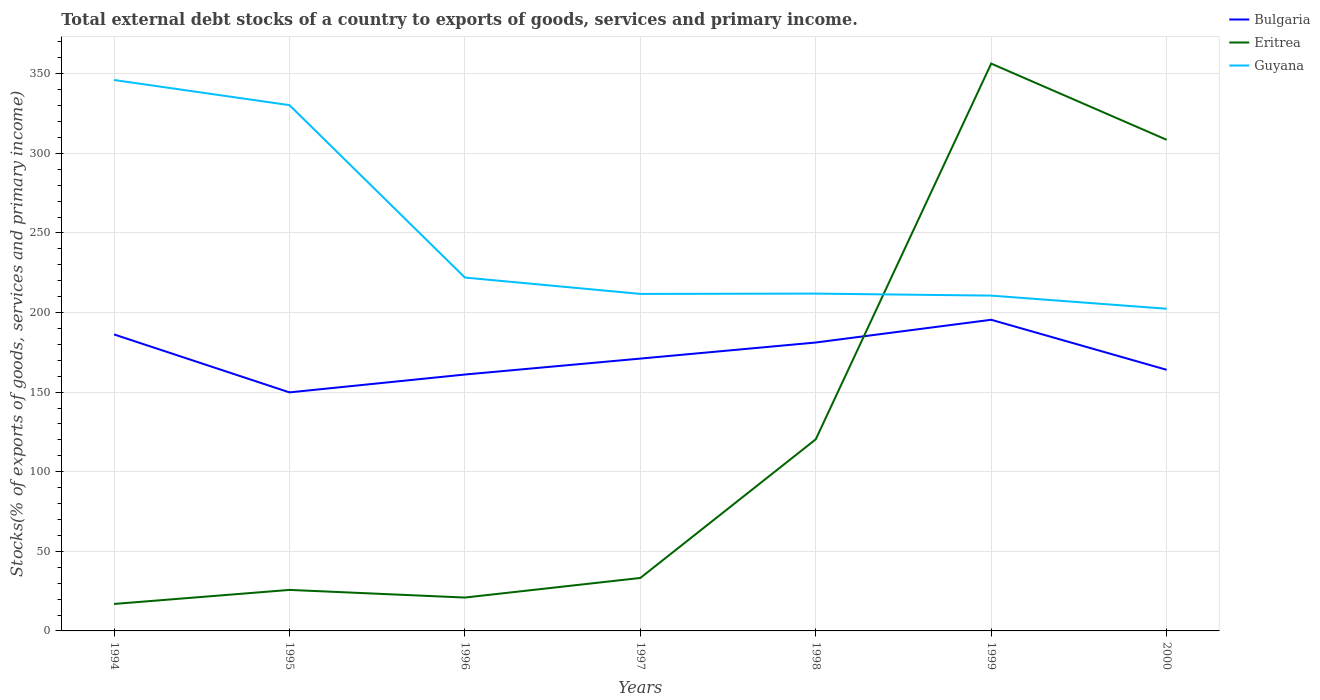How many different coloured lines are there?
Make the answer very short. 3. Does the line corresponding to Guyana intersect with the line corresponding to Bulgaria?
Provide a short and direct response. No. Is the number of lines equal to the number of legend labels?
Your answer should be compact. Yes. Across all years, what is the maximum total debt stocks in Eritrea?
Ensure brevity in your answer.  16.94. What is the total total debt stocks in Bulgaria in the graph?
Make the answer very short. -11.22. What is the difference between the highest and the second highest total debt stocks in Guyana?
Make the answer very short. 143.7. What is the difference between the highest and the lowest total debt stocks in Bulgaria?
Make the answer very short. 3. How many years are there in the graph?
Offer a terse response. 7. Are the values on the major ticks of Y-axis written in scientific E-notation?
Your answer should be very brief. No. What is the title of the graph?
Your answer should be compact. Total external debt stocks of a country to exports of goods, services and primary income. Does "Northern Mariana Islands" appear as one of the legend labels in the graph?
Offer a terse response. No. What is the label or title of the Y-axis?
Your response must be concise. Stocks(% of exports of goods, services and primary income). What is the Stocks(% of exports of goods, services and primary income) of Bulgaria in 1994?
Give a very brief answer. 186.26. What is the Stocks(% of exports of goods, services and primary income) of Eritrea in 1994?
Provide a succinct answer. 16.94. What is the Stocks(% of exports of goods, services and primary income) in Guyana in 1994?
Offer a very short reply. 346.09. What is the Stocks(% of exports of goods, services and primary income) in Bulgaria in 1995?
Your answer should be very brief. 149.85. What is the Stocks(% of exports of goods, services and primary income) of Eritrea in 1995?
Your answer should be very brief. 25.77. What is the Stocks(% of exports of goods, services and primary income) of Guyana in 1995?
Offer a terse response. 330.29. What is the Stocks(% of exports of goods, services and primary income) of Bulgaria in 1996?
Offer a terse response. 161.07. What is the Stocks(% of exports of goods, services and primary income) of Eritrea in 1996?
Provide a succinct answer. 20.97. What is the Stocks(% of exports of goods, services and primary income) in Guyana in 1996?
Offer a very short reply. 221.99. What is the Stocks(% of exports of goods, services and primary income) in Bulgaria in 1997?
Your response must be concise. 171.08. What is the Stocks(% of exports of goods, services and primary income) of Eritrea in 1997?
Make the answer very short. 33.27. What is the Stocks(% of exports of goods, services and primary income) in Guyana in 1997?
Your answer should be compact. 211.71. What is the Stocks(% of exports of goods, services and primary income) in Bulgaria in 1998?
Keep it short and to the point. 181.18. What is the Stocks(% of exports of goods, services and primary income) in Eritrea in 1998?
Make the answer very short. 120.36. What is the Stocks(% of exports of goods, services and primary income) of Guyana in 1998?
Give a very brief answer. 211.9. What is the Stocks(% of exports of goods, services and primary income) in Bulgaria in 1999?
Give a very brief answer. 195.46. What is the Stocks(% of exports of goods, services and primary income) in Eritrea in 1999?
Keep it short and to the point. 356.4. What is the Stocks(% of exports of goods, services and primary income) of Guyana in 1999?
Your answer should be compact. 210.64. What is the Stocks(% of exports of goods, services and primary income) of Bulgaria in 2000?
Your answer should be very brief. 164.04. What is the Stocks(% of exports of goods, services and primary income) in Eritrea in 2000?
Your response must be concise. 308.53. What is the Stocks(% of exports of goods, services and primary income) in Guyana in 2000?
Ensure brevity in your answer.  202.39. Across all years, what is the maximum Stocks(% of exports of goods, services and primary income) in Bulgaria?
Make the answer very short. 195.46. Across all years, what is the maximum Stocks(% of exports of goods, services and primary income) in Eritrea?
Offer a very short reply. 356.4. Across all years, what is the maximum Stocks(% of exports of goods, services and primary income) of Guyana?
Offer a very short reply. 346.09. Across all years, what is the minimum Stocks(% of exports of goods, services and primary income) of Bulgaria?
Ensure brevity in your answer.  149.85. Across all years, what is the minimum Stocks(% of exports of goods, services and primary income) in Eritrea?
Make the answer very short. 16.94. Across all years, what is the minimum Stocks(% of exports of goods, services and primary income) in Guyana?
Ensure brevity in your answer.  202.39. What is the total Stocks(% of exports of goods, services and primary income) in Bulgaria in the graph?
Ensure brevity in your answer.  1208.94. What is the total Stocks(% of exports of goods, services and primary income) in Eritrea in the graph?
Your response must be concise. 882.24. What is the total Stocks(% of exports of goods, services and primary income) in Guyana in the graph?
Your answer should be compact. 1735.02. What is the difference between the Stocks(% of exports of goods, services and primary income) of Bulgaria in 1994 and that in 1995?
Your answer should be compact. 36.41. What is the difference between the Stocks(% of exports of goods, services and primary income) of Eritrea in 1994 and that in 1995?
Keep it short and to the point. -8.82. What is the difference between the Stocks(% of exports of goods, services and primary income) of Guyana in 1994 and that in 1995?
Your answer should be very brief. 15.79. What is the difference between the Stocks(% of exports of goods, services and primary income) of Bulgaria in 1994 and that in 1996?
Ensure brevity in your answer.  25.19. What is the difference between the Stocks(% of exports of goods, services and primary income) in Eritrea in 1994 and that in 1996?
Make the answer very short. -4.03. What is the difference between the Stocks(% of exports of goods, services and primary income) of Guyana in 1994 and that in 1996?
Provide a succinct answer. 124.1. What is the difference between the Stocks(% of exports of goods, services and primary income) in Bulgaria in 1994 and that in 1997?
Your answer should be very brief. 15.18. What is the difference between the Stocks(% of exports of goods, services and primary income) in Eritrea in 1994 and that in 1997?
Your response must be concise. -16.33. What is the difference between the Stocks(% of exports of goods, services and primary income) of Guyana in 1994 and that in 1997?
Your answer should be compact. 134.38. What is the difference between the Stocks(% of exports of goods, services and primary income) in Bulgaria in 1994 and that in 1998?
Ensure brevity in your answer.  5.08. What is the difference between the Stocks(% of exports of goods, services and primary income) of Eritrea in 1994 and that in 1998?
Offer a terse response. -103.42. What is the difference between the Stocks(% of exports of goods, services and primary income) in Guyana in 1994 and that in 1998?
Offer a very short reply. 134.19. What is the difference between the Stocks(% of exports of goods, services and primary income) of Bulgaria in 1994 and that in 1999?
Provide a succinct answer. -9.2. What is the difference between the Stocks(% of exports of goods, services and primary income) of Eritrea in 1994 and that in 1999?
Your answer should be compact. -339.45. What is the difference between the Stocks(% of exports of goods, services and primary income) in Guyana in 1994 and that in 1999?
Your response must be concise. 135.45. What is the difference between the Stocks(% of exports of goods, services and primary income) in Bulgaria in 1994 and that in 2000?
Offer a terse response. 22.22. What is the difference between the Stocks(% of exports of goods, services and primary income) in Eritrea in 1994 and that in 2000?
Make the answer very short. -291.59. What is the difference between the Stocks(% of exports of goods, services and primary income) of Guyana in 1994 and that in 2000?
Give a very brief answer. 143.7. What is the difference between the Stocks(% of exports of goods, services and primary income) of Bulgaria in 1995 and that in 1996?
Offer a very short reply. -11.22. What is the difference between the Stocks(% of exports of goods, services and primary income) in Eritrea in 1995 and that in 1996?
Provide a short and direct response. 4.8. What is the difference between the Stocks(% of exports of goods, services and primary income) in Guyana in 1995 and that in 1996?
Your answer should be compact. 108.3. What is the difference between the Stocks(% of exports of goods, services and primary income) of Bulgaria in 1995 and that in 1997?
Keep it short and to the point. -21.23. What is the difference between the Stocks(% of exports of goods, services and primary income) of Eritrea in 1995 and that in 1997?
Keep it short and to the point. -7.5. What is the difference between the Stocks(% of exports of goods, services and primary income) in Guyana in 1995 and that in 1997?
Give a very brief answer. 118.58. What is the difference between the Stocks(% of exports of goods, services and primary income) in Bulgaria in 1995 and that in 1998?
Provide a short and direct response. -31.33. What is the difference between the Stocks(% of exports of goods, services and primary income) in Eritrea in 1995 and that in 1998?
Your response must be concise. -94.6. What is the difference between the Stocks(% of exports of goods, services and primary income) in Guyana in 1995 and that in 1998?
Offer a terse response. 118.39. What is the difference between the Stocks(% of exports of goods, services and primary income) of Bulgaria in 1995 and that in 1999?
Offer a terse response. -45.61. What is the difference between the Stocks(% of exports of goods, services and primary income) of Eritrea in 1995 and that in 1999?
Offer a terse response. -330.63. What is the difference between the Stocks(% of exports of goods, services and primary income) of Guyana in 1995 and that in 1999?
Provide a short and direct response. 119.65. What is the difference between the Stocks(% of exports of goods, services and primary income) of Bulgaria in 1995 and that in 2000?
Your response must be concise. -14.19. What is the difference between the Stocks(% of exports of goods, services and primary income) of Eritrea in 1995 and that in 2000?
Provide a succinct answer. -282.76. What is the difference between the Stocks(% of exports of goods, services and primary income) of Guyana in 1995 and that in 2000?
Keep it short and to the point. 127.9. What is the difference between the Stocks(% of exports of goods, services and primary income) in Bulgaria in 1996 and that in 1997?
Offer a terse response. -10.01. What is the difference between the Stocks(% of exports of goods, services and primary income) in Eritrea in 1996 and that in 1997?
Make the answer very short. -12.3. What is the difference between the Stocks(% of exports of goods, services and primary income) in Guyana in 1996 and that in 1997?
Provide a short and direct response. 10.28. What is the difference between the Stocks(% of exports of goods, services and primary income) in Bulgaria in 1996 and that in 1998?
Give a very brief answer. -20.11. What is the difference between the Stocks(% of exports of goods, services and primary income) in Eritrea in 1996 and that in 1998?
Your answer should be compact. -99.39. What is the difference between the Stocks(% of exports of goods, services and primary income) in Guyana in 1996 and that in 1998?
Keep it short and to the point. 10.09. What is the difference between the Stocks(% of exports of goods, services and primary income) of Bulgaria in 1996 and that in 1999?
Offer a very short reply. -34.39. What is the difference between the Stocks(% of exports of goods, services and primary income) of Eritrea in 1996 and that in 1999?
Offer a terse response. -335.43. What is the difference between the Stocks(% of exports of goods, services and primary income) in Guyana in 1996 and that in 1999?
Your answer should be very brief. 11.35. What is the difference between the Stocks(% of exports of goods, services and primary income) in Bulgaria in 1996 and that in 2000?
Offer a terse response. -2.97. What is the difference between the Stocks(% of exports of goods, services and primary income) of Eritrea in 1996 and that in 2000?
Offer a terse response. -287.56. What is the difference between the Stocks(% of exports of goods, services and primary income) of Guyana in 1996 and that in 2000?
Give a very brief answer. 19.6. What is the difference between the Stocks(% of exports of goods, services and primary income) of Bulgaria in 1997 and that in 1998?
Offer a terse response. -10.1. What is the difference between the Stocks(% of exports of goods, services and primary income) in Eritrea in 1997 and that in 1998?
Make the answer very short. -87.09. What is the difference between the Stocks(% of exports of goods, services and primary income) in Guyana in 1997 and that in 1998?
Offer a terse response. -0.19. What is the difference between the Stocks(% of exports of goods, services and primary income) in Bulgaria in 1997 and that in 1999?
Your response must be concise. -24.38. What is the difference between the Stocks(% of exports of goods, services and primary income) in Eritrea in 1997 and that in 1999?
Ensure brevity in your answer.  -323.12. What is the difference between the Stocks(% of exports of goods, services and primary income) of Guyana in 1997 and that in 1999?
Give a very brief answer. 1.07. What is the difference between the Stocks(% of exports of goods, services and primary income) in Bulgaria in 1997 and that in 2000?
Give a very brief answer. 7.04. What is the difference between the Stocks(% of exports of goods, services and primary income) of Eritrea in 1997 and that in 2000?
Your answer should be very brief. -275.26. What is the difference between the Stocks(% of exports of goods, services and primary income) in Guyana in 1997 and that in 2000?
Give a very brief answer. 9.32. What is the difference between the Stocks(% of exports of goods, services and primary income) in Bulgaria in 1998 and that in 1999?
Your answer should be compact. -14.28. What is the difference between the Stocks(% of exports of goods, services and primary income) of Eritrea in 1998 and that in 1999?
Offer a very short reply. -236.03. What is the difference between the Stocks(% of exports of goods, services and primary income) of Guyana in 1998 and that in 1999?
Ensure brevity in your answer.  1.26. What is the difference between the Stocks(% of exports of goods, services and primary income) of Bulgaria in 1998 and that in 2000?
Give a very brief answer. 17.14. What is the difference between the Stocks(% of exports of goods, services and primary income) in Eritrea in 1998 and that in 2000?
Your answer should be compact. -188.17. What is the difference between the Stocks(% of exports of goods, services and primary income) in Guyana in 1998 and that in 2000?
Offer a terse response. 9.51. What is the difference between the Stocks(% of exports of goods, services and primary income) in Bulgaria in 1999 and that in 2000?
Make the answer very short. 31.42. What is the difference between the Stocks(% of exports of goods, services and primary income) in Eritrea in 1999 and that in 2000?
Ensure brevity in your answer.  47.86. What is the difference between the Stocks(% of exports of goods, services and primary income) in Guyana in 1999 and that in 2000?
Ensure brevity in your answer.  8.25. What is the difference between the Stocks(% of exports of goods, services and primary income) of Bulgaria in 1994 and the Stocks(% of exports of goods, services and primary income) of Eritrea in 1995?
Keep it short and to the point. 160.5. What is the difference between the Stocks(% of exports of goods, services and primary income) of Bulgaria in 1994 and the Stocks(% of exports of goods, services and primary income) of Guyana in 1995?
Ensure brevity in your answer.  -144.03. What is the difference between the Stocks(% of exports of goods, services and primary income) of Eritrea in 1994 and the Stocks(% of exports of goods, services and primary income) of Guyana in 1995?
Make the answer very short. -313.35. What is the difference between the Stocks(% of exports of goods, services and primary income) of Bulgaria in 1994 and the Stocks(% of exports of goods, services and primary income) of Eritrea in 1996?
Give a very brief answer. 165.29. What is the difference between the Stocks(% of exports of goods, services and primary income) in Bulgaria in 1994 and the Stocks(% of exports of goods, services and primary income) in Guyana in 1996?
Your answer should be very brief. -35.73. What is the difference between the Stocks(% of exports of goods, services and primary income) of Eritrea in 1994 and the Stocks(% of exports of goods, services and primary income) of Guyana in 1996?
Offer a terse response. -205.05. What is the difference between the Stocks(% of exports of goods, services and primary income) of Bulgaria in 1994 and the Stocks(% of exports of goods, services and primary income) of Eritrea in 1997?
Offer a very short reply. 152.99. What is the difference between the Stocks(% of exports of goods, services and primary income) of Bulgaria in 1994 and the Stocks(% of exports of goods, services and primary income) of Guyana in 1997?
Provide a succinct answer. -25.45. What is the difference between the Stocks(% of exports of goods, services and primary income) of Eritrea in 1994 and the Stocks(% of exports of goods, services and primary income) of Guyana in 1997?
Offer a very short reply. -194.77. What is the difference between the Stocks(% of exports of goods, services and primary income) in Bulgaria in 1994 and the Stocks(% of exports of goods, services and primary income) in Eritrea in 1998?
Your answer should be compact. 65.9. What is the difference between the Stocks(% of exports of goods, services and primary income) of Bulgaria in 1994 and the Stocks(% of exports of goods, services and primary income) of Guyana in 1998?
Give a very brief answer. -25.64. What is the difference between the Stocks(% of exports of goods, services and primary income) of Eritrea in 1994 and the Stocks(% of exports of goods, services and primary income) of Guyana in 1998?
Ensure brevity in your answer.  -194.96. What is the difference between the Stocks(% of exports of goods, services and primary income) of Bulgaria in 1994 and the Stocks(% of exports of goods, services and primary income) of Eritrea in 1999?
Provide a short and direct response. -170.13. What is the difference between the Stocks(% of exports of goods, services and primary income) of Bulgaria in 1994 and the Stocks(% of exports of goods, services and primary income) of Guyana in 1999?
Keep it short and to the point. -24.38. What is the difference between the Stocks(% of exports of goods, services and primary income) of Eritrea in 1994 and the Stocks(% of exports of goods, services and primary income) of Guyana in 1999?
Your response must be concise. -193.7. What is the difference between the Stocks(% of exports of goods, services and primary income) of Bulgaria in 1994 and the Stocks(% of exports of goods, services and primary income) of Eritrea in 2000?
Your response must be concise. -122.27. What is the difference between the Stocks(% of exports of goods, services and primary income) in Bulgaria in 1994 and the Stocks(% of exports of goods, services and primary income) in Guyana in 2000?
Ensure brevity in your answer.  -16.13. What is the difference between the Stocks(% of exports of goods, services and primary income) in Eritrea in 1994 and the Stocks(% of exports of goods, services and primary income) in Guyana in 2000?
Ensure brevity in your answer.  -185.45. What is the difference between the Stocks(% of exports of goods, services and primary income) in Bulgaria in 1995 and the Stocks(% of exports of goods, services and primary income) in Eritrea in 1996?
Provide a succinct answer. 128.88. What is the difference between the Stocks(% of exports of goods, services and primary income) of Bulgaria in 1995 and the Stocks(% of exports of goods, services and primary income) of Guyana in 1996?
Offer a very short reply. -72.14. What is the difference between the Stocks(% of exports of goods, services and primary income) of Eritrea in 1995 and the Stocks(% of exports of goods, services and primary income) of Guyana in 1996?
Your response must be concise. -196.22. What is the difference between the Stocks(% of exports of goods, services and primary income) of Bulgaria in 1995 and the Stocks(% of exports of goods, services and primary income) of Eritrea in 1997?
Keep it short and to the point. 116.58. What is the difference between the Stocks(% of exports of goods, services and primary income) in Bulgaria in 1995 and the Stocks(% of exports of goods, services and primary income) in Guyana in 1997?
Offer a terse response. -61.87. What is the difference between the Stocks(% of exports of goods, services and primary income) of Eritrea in 1995 and the Stocks(% of exports of goods, services and primary income) of Guyana in 1997?
Give a very brief answer. -185.95. What is the difference between the Stocks(% of exports of goods, services and primary income) of Bulgaria in 1995 and the Stocks(% of exports of goods, services and primary income) of Eritrea in 1998?
Make the answer very short. 29.49. What is the difference between the Stocks(% of exports of goods, services and primary income) in Bulgaria in 1995 and the Stocks(% of exports of goods, services and primary income) in Guyana in 1998?
Your response must be concise. -62.05. What is the difference between the Stocks(% of exports of goods, services and primary income) in Eritrea in 1995 and the Stocks(% of exports of goods, services and primary income) in Guyana in 1998?
Provide a succinct answer. -186.13. What is the difference between the Stocks(% of exports of goods, services and primary income) of Bulgaria in 1995 and the Stocks(% of exports of goods, services and primary income) of Eritrea in 1999?
Your answer should be very brief. -206.55. What is the difference between the Stocks(% of exports of goods, services and primary income) in Bulgaria in 1995 and the Stocks(% of exports of goods, services and primary income) in Guyana in 1999?
Provide a succinct answer. -60.79. What is the difference between the Stocks(% of exports of goods, services and primary income) of Eritrea in 1995 and the Stocks(% of exports of goods, services and primary income) of Guyana in 1999?
Offer a terse response. -184.88. What is the difference between the Stocks(% of exports of goods, services and primary income) of Bulgaria in 1995 and the Stocks(% of exports of goods, services and primary income) of Eritrea in 2000?
Your response must be concise. -158.68. What is the difference between the Stocks(% of exports of goods, services and primary income) of Bulgaria in 1995 and the Stocks(% of exports of goods, services and primary income) of Guyana in 2000?
Your answer should be very brief. -52.54. What is the difference between the Stocks(% of exports of goods, services and primary income) of Eritrea in 1995 and the Stocks(% of exports of goods, services and primary income) of Guyana in 2000?
Offer a very short reply. -176.62. What is the difference between the Stocks(% of exports of goods, services and primary income) in Bulgaria in 1996 and the Stocks(% of exports of goods, services and primary income) in Eritrea in 1997?
Ensure brevity in your answer.  127.8. What is the difference between the Stocks(% of exports of goods, services and primary income) in Bulgaria in 1996 and the Stocks(% of exports of goods, services and primary income) in Guyana in 1997?
Make the answer very short. -50.64. What is the difference between the Stocks(% of exports of goods, services and primary income) of Eritrea in 1996 and the Stocks(% of exports of goods, services and primary income) of Guyana in 1997?
Your answer should be compact. -190.74. What is the difference between the Stocks(% of exports of goods, services and primary income) of Bulgaria in 1996 and the Stocks(% of exports of goods, services and primary income) of Eritrea in 1998?
Provide a succinct answer. 40.71. What is the difference between the Stocks(% of exports of goods, services and primary income) in Bulgaria in 1996 and the Stocks(% of exports of goods, services and primary income) in Guyana in 1998?
Make the answer very short. -50.83. What is the difference between the Stocks(% of exports of goods, services and primary income) in Eritrea in 1996 and the Stocks(% of exports of goods, services and primary income) in Guyana in 1998?
Your answer should be compact. -190.93. What is the difference between the Stocks(% of exports of goods, services and primary income) in Bulgaria in 1996 and the Stocks(% of exports of goods, services and primary income) in Eritrea in 1999?
Offer a very short reply. -195.33. What is the difference between the Stocks(% of exports of goods, services and primary income) in Bulgaria in 1996 and the Stocks(% of exports of goods, services and primary income) in Guyana in 1999?
Provide a succinct answer. -49.57. What is the difference between the Stocks(% of exports of goods, services and primary income) of Eritrea in 1996 and the Stocks(% of exports of goods, services and primary income) of Guyana in 1999?
Ensure brevity in your answer.  -189.67. What is the difference between the Stocks(% of exports of goods, services and primary income) in Bulgaria in 1996 and the Stocks(% of exports of goods, services and primary income) in Eritrea in 2000?
Make the answer very short. -147.46. What is the difference between the Stocks(% of exports of goods, services and primary income) of Bulgaria in 1996 and the Stocks(% of exports of goods, services and primary income) of Guyana in 2000?
Provide a short and direct response. -41.32. What is the difference between the Stocks(% of exports of goods, services and primary income) in Eritrea in 1996 and the Stocks(% of exports of goods, services and primary income) in Guyana in 2000?
Offer a very short reply. -181.42. What is the difference between the Stocks(% of exports of goods, services and primary income) in Bulgaria in 1997 and the Stocks(% of exports of goods, services and primary income) in Eritrea in 1998?
Offer a terse response. 50.72. What is the difference between the Stocks(% of exports of goods, services and primary income) of Bulgaria in 1997 and the Stocks(% of exports of goods, services and primary income) of Guyana in 1998?
Offer a very short reply. -40.82. What is the difference between the Stocks(% of exports of goods, services and primary income) in Eritrea in 1997 and the Stocks(% of exports of goods, services and primary income) in Guyana in 1998?
Make the answer very short. -178.63. What is the difference between the Stocks(% of exports of goods, services and primary income) in Bulgaria in 1997 and the Stocks(% of exports of goods, services and primary income) in Eritrea in 1999?
Provide a short and direct response. -185.31. What is the difference between the Stocks(% of exports of goods, services and primary income) in Bulgaria in 1997 and the Stocks(% of exports of goods, services and primary income) in Guyana in 1999?
Your response must be concise. -39.56. What is the difference between the Stocks(% of exports of goods, services and primary income) in Eritrea in 1997 and the Stocks(% of exports of goods, services and primary income) in Guyana in 1999?
Your answer should be very brief. -177.37. What is the difference between the Stocks(% of exports of goods, services and primary income) in Bulgaria in 1997 and the Stocks(% of exports of goods, services and primary income) in Eritrea in 2000?
Make the answer very short. -137.45. What is the difference between the Stocks(% of exports of goods, services and primary income) of Bulgaria in 1997 and the Stocks(% of exports of goods, services and primary income) of Guyana in 2000?
Your answer should be compact. -31.31. What is the difference between the Stocks(% of exports of goods, services and primary income) of Eritrea in 1997 and the Stocks(% of exports of goods, services and primary income) of Guyana in 2000?
Your answer should be compact. -169.12. What is the difference between the Stocks(% of exports of goods, services and primary income) of Bulgaria in 1998 and the Stocks(% of exports of goods, services and primary income) of Eritrea in 1999?
Your answer should be very brief. -175.22. What is the difference between the Stocks(% of exports of goods, services and primary income) in Bulgaria in 1998 and the Stocks(% of exports of goods, services and primary income) in Guyana in 1999?
Give a very brief answer. -29.46. What is the difference between the Stocks(% of exports of goods, services and primary income) of Eritrea in 1998 and the Stocks(% of exports of goods, services and primary income) of Guyana in 1999?
Your response must be concise. -90.28. What is the difference between the Stocks(% of exports of goods, services and primary income) in Bulgaria in 1998 and the Stocks(% of exports of goods, services and primary income) in Eritrea in 2000?
Offer a terse response. -127.35. What is the difference between the Stocks(% of exports of goods, services and primary income) of Bulgaria in 1998 and the Stocks(% of exports of goods, services and primary income) of Guyana in 2000?
Your response must be concise. -21.21. What is the difference between the Stocks(% of exports of goods, services and primary income) in Eritrea in 1998 and the Stocks(% of exports of goods, services and primary income) in Guyana in 2000?
Your response must be concise. -82.03. What is the difference between the Stocks(% of exports of goods, services and primary income) of Bulgaria in 1999 and the Stocks(% of exports of goods, services and primary income) of Eritrea in 2000?
Your response must be concise. -113.07. What is the difference between the Stocks(% of exports of goods, services and primary income) of Bulgaria in 1999 and the Stocks(% of exports of goods, services and primary income) of Guyana in 2000?
Provide a succinct answer. -6.93. What is the difference between the Stocks(% of exports of goods, services and primary income) in Eritrea in 1999 and the Stocks(% of exports of goods, services and primary income) in Guyana in 2000?
Keep it short and to the point. 154.01. What is the average Stocks(% of exports of goods, services and primary income) of Bulgaria per year?
Keep it short and to the point. 172.71. What is the average Stocks(% of exports of goods, services and primary income) in Eritrea per year?
Offer a very short reply. 126.03. What is the average Stocks(% of exports of goods, services and primary income) of Guyana per year?
Ensure brevity in your answer.  247.86. In the year 1994, what is the difference between the Stocks(% of exports of goods, services and primary income) of Bulgaria and Stocks(% of exports of goods, services and primary income) of Eritrea?
Provide a short and direct response. 169.32. In the year 1994, what is the difference between the Stocks(% of exports of goods, services and primary income) in Bulgaria and Stocks(% of exports of goods, services and primary income) in Guyana?
Give a very brief answer. -159.83. In the year 1994, what is the difference between the Stocks(% of exports of goods, services and primary income) in Eritrea and Stocks(% of exports of goods, services and primary income) in Guyana?
Keep it short and to the point. -329.15. In the year 1995, what is the difference between the Stocks(% of exports of goods, services and primary income) of Bulgaria and Stocks(% of exports of goods, services and primary income) of Eritrea?
Make the answer very short. 124.08. In the year 1995, what is the difference between the Stocks(% of exports of goods, services and primary income) in Bulgaria and Stocks(% of exports of goods, services and primary income) in Guyana?
Your response must be concise. -180.45. In the year 1995, what is the difference between the Stocks(% of exports of goods, services and primary income) in Eritrea and Stocks(% of exports of goods, services and primary income) in Guyana?
Your answer should be very brief. -304.53. In the year 1996, what is the difference between the Stocks(% of exports of goods, services and primary income) of Bulgaria and Stocks(% of exports of goods, services and primary income) of Eritrea?
Your answer should be very brief. 140.1. In the year 1996, what is the difference between the Stocks(% of exports of goods, services and primary income) of Bulgaria and Stocks(% of exports of goods, services and primary income) of Guyana?
Offer a very short reply. -60.92. In the year 1996, what is the difference between the Stocks(% of exports of goods, services and primary income) of Eritrea and Stocks(% of exports of goods, services and primary income) of Guyana?
Give a very brief answer. -201.02. In the year 1997, what is the difference between the Stocks(% of exports of goods, services and primary income) of Bulgaria and Stocks(% of exports of goods, services and primary income) of Eritrea?
Your answer should be very brief. 137.81. In the year 1997, what is the difference between the Stocks(% of exports of goods, services and primary income) of Bulgaria and Stocks(% of exports of goods, services and primary income) of Guyana?
Make the answer very short. -40.63. In the year 1997, what is the difference between the Stocks(% of exports of goods, services and primary income) in Eritrea and Stocks(% of exports of goods, services and primary income) in Guyana?
Your response must be concise. -178.44. In the year 1998, what is the difference between the Stocks(% of exports of goods, services and primary income) in Bulgaria and Stocks(% of exports of goods, services and primary income) in Eritrea?
Provide a succinct answer. 60.82. In the year 1998, what is the difference between the Stocks(% of exports of goods, services and primary income) in Bulgaria and Stocks(% of exports of goods, services and primary income) in Guyana?
Your answer should be very brief. -30.72. In the year 1998, what is the difference between the Stocks(% of exports of goods, services and primary income) of Eritrea and Stocks(% of exports of goods, services and primary income) of Guyana?
Your answer should be very brief. -91.54. In the year 1999, what is the difference between the Stocks(% of exports of goods, services and primary income) in Bulgaria and Stocks(% of exports of goods, services and primary income) in Eritrea?
Your answer should be compact. -160.94. In the year 1999, what is the difference between the Stocks(% of exports of goods, services and primary income) in Bulgaria and Stocks(% of exports of goods, services and primary income) in Guyana?
Offer a terse response. -15.18. In the year 1999, what is the difference between the Stocks(% of exports of goods, services and primary income) of Eritrea and Stocks(% of exports of goods, services and primary income) of Guyana?
Give a very brief answer. 145.75. In the year 2000, what is the difference between the Stocks(% of exports of goods, services and primary income) of Bulgaria and Stocks(% of exports of goods, services and primary income) of Eritrea?
Give a very brief answer. -144.49. In the year 2000, what is the difference between the Stocks(% of exports of goods, services and primary income) of Bulgaria and Stocks(% of exports of goods, services and primary income) of Guyana?
Give a very brief answer. -38.35. In the year 2000, what is the difference between the Stocks(% of exports of goods, services and primary income) of Eritrea and Stocks(% of exports of goods, services and primary income) of Guyana?
Offer a terse response. 106.14. What is the ratio of the Stocks(% of exports of goods, services and primary income) in Bulgaria in 1994 to that in 1995?
Your response must be concise. 1.24. What is the ratio of the Stocks(% of exports of goods, services and primary income) of Eritrea in 1994 to that in 1995?
Provide a succinct answer. 0.66. What is the ratio of the Stocks(% of exports of goods, services and primary income) of Guyana in 1994 to that in 1995?
Your response must be concise. 1.05. What is the ratio of the Stocks(% of exports of goods, services and primary income) of Bulgaria in 1994 to that in 1996?
Keep it short and to the point. 1.16. What is the ratio of the Stocks(% of exports of goods, services and primary income) of Eritrea in 1994 to that in 1996?
Provide a short and direct response. 0.81. What is the ratio of the Stocks(% of exports of goods, services and primary income) of Guyana in 1994 to that in 1996?
Give a very brief answer. 1.56. What is the ratio of the Stocks(% of exports of goods, services and primary income) of Bulgaria in 1994 to that in 1997?
Keep it short and to the point. 1.09. What is the ratio of the Stocks(% of exports of goods, services and primary income) of Eritrea in 1994 to that in 1997?
Offer a very short reply. 0.51. What is the ratio of the Stocks(% of exports of goods, services and primary income) of Guyana in 1994 to that in 1997?
Give a very brief answer. 1.63. What is the ratio of the Stocks(% of exports of goods, services and primary income) in Bulgaria in 1994 to that in 1998?
Ensure brevity in your answer.  1.03. What is the ratio of the Stocks(% of exports of goods, services and primary income) in Eritrea in 1994 to that in 1998?
Keep it short and to the point. 0.14. What is the ratio of the Stocks(% of exports of goods, services and primary income) in Guyana in 1994 to that in 1998?
Ensure brevity in your answer.  1.63. What is the ratio of the Stocks(% of exports of goods, services and primary income) of Bulgaria in 1994 to that in 1999?
Provide a succinct answer. 0.95. What is the ratio of the Stocks(% of exports of goods, services and primary income) in Eritrea in 1994 to that in 1999?
Give a very brief answer. 0.05. What is the ratio of the Stocks(% of exports of goods, services and primary income) of Guyana in 1994 to that in 1999?
Your response must be concise. 1.64. What is the ratio of the Stocks(% of exports of goods, services and primary income) in Bulgaria in 1994 to that in 2000?
Give a very brief answer. 1.14. What is the ratio of the Stocks(% of exports of goods, services and primary income) of Eritrea in 1994 to that in 2000?
Offer a very short reply. 0.05. What is the ratio of the Stocks(% of exports of goods, services and primary income) in Guyana in 1994 to that in 2000?
Your response must be concise. 1.71. What is the ratio of the Stocks(% of exports of goods, services and primary income) in Bulgaria in 1995 to that in 1996?
Your answer should be very brief. 0.93. What is the ratio of the Stocks(% of exports of goods, services and primary income) in Eritrea in 1995 to that in 1996?
Your answer should be compact. 1.23. What is the ratio of the Stocks(% of exports of goods, services and primary income) of Guyana in 1995 to that in 1996?
Keep it short and to the point. 1.49. What is the ratio of the Stocks(% of exports of goods, services and primary income) of Bulgaria in 1995 to that in 1997?
Make the answer very short. 0.88. What is the ratio of the Stocks(% of exports of goods, services and primary income) in Eritrea in 1995 to that in 1997?
Provide a short and direct response. 0.77. What is the ratio of the Stocks(% of exports of goods, services and primary income) of Guyana in 1995 to that in 1997?
Your response must be concise. 1.56. What is the ratio of the Stocks(% of exports of goods, services and primary income) in Bulgaria in 1995 to that in 1998?
Your response must be concise. 0.83. What is the ratio of the Stocks(% of exports of goods, services and primary income) in Eritrea in 1995 to that in 1998?
Ensure brevity in your answer.  0.21. What is the ratio of the Stocks(% of exports of goods, services and primary income) in Guyana in 1995 to that in 1998?
Your answer should be compact. 1.56. What is the ratio of the Stocks(% of exports of goods, services and primary income) in Bulgaria in 1995 to that in 1999?
Keep it short and to the point. 0.77. What is the ratio of the Stocks(% of exports of goods, services and primary income) in Eritrea in 1995 to that in 1999?
Your answer should be very brief. 0.07. What is the ratio of the Stocks(% of exports of goods, services and primary income) in Guyana in 1995 to that in 1999?
Keep it short and to the point. 1.57. What is the ratio of the Stocks(% of exports of goods, services and primary income) in Bulgaria in 1995 to that in 2000?
Give a very brief answer. 0.91. What is the ratio of the Stocks(% of exports of goods, services and primary income) in Eritrea in 1995 to that in 2000?
Provide a succinct answer. 0.08. What is the ratio of the Stocks(% of exports of goods, services and primary income) of Guyana in 1995 to that in 2000?
Your response must be concise. 1.63. What is the ratio of the Stocks(% of exports of goods, services and primary income) in Bulgaria in 1996 to that in 1997?
Provide a succinct answer. 0.94. What is the ratio of the Stocks(% of exports of goods, services and primary income) in Eritrea in 1996 to that in 1997?
Your answer should be very brief. 0.63. What is the ratio of the Stocks(% of exports of goods, services and primary income) of Guyana in 1996 to that in 1997?
Your answer should be compact. 1.05. What is the ratio of the Stocks(% of exports of goods, services and primary income) in Bulgaria in 1996 to that in 1998?
Make the answer very short. 0.89. What is the ratio of the Stocks(% of exports of goods, services and primary income) in Eritrea in 1996 to that in 1998?
Ensure brevity in your answer.  0.17. What is the ratio of the Stocks(% of exports of goods, services and primary income) of Guyana in 1996 to that in 1998?
Keep it short and to the point. 1.05. What is the ratio of the Stocks(% of exports of goods, services and primary income) in Bulgaria in 1996 to that in 1999?
Offer a terse response. 0.82. What is the ratio of the Stocks(% of exports of goods, services and primary income) in Eritrea in 1996 to that in 1999?
Your answer should be very brief. 0.06. What is the ratio of the Stocks(% of exports of goods, services and primary income) of Guyana in 1996 to that in 1999?
Provide a short and direct response. 1.05. What is the ratio of the Stocks(% of exports of goods, services and primary income) of Bulgaria in 1996 to that in 2000?
Ensure brevity in your answer.  0.98. What is the ratio of the Stocks(% of exports of goods, services and primary income) of Eritrea in 1996 to that in 2000?
Your answer should be very brief. 0.07. What is the ratio of the Stocks(% of exports of goods, services and primary income) of Guyana in 1996 to that in 2000?
Provide a succinct answer. 1.1. What is the ratio of the Stocks(% of exports of goods, services and primary income) in Bulgaria in 1997 to that in 1998?
Provide a short and direct response. 0.94. What is the ratio of the Stocks(% of exports of goods, services and primary income) in Eritrea in 1997 to that in 1998?
Ensure brevity in your answer.  0.28. What is the ratio of the Stocks(% of exports of goods, services and primary income) in Bulgaria in 1997 to that in 1999?
Ensure brevity in your answer.  0.88. What is the ratio of the Stocks(% of exports of goods, services and primary income) in Eritrea in 1997 to that in 1999?
Provide a short and direct response. 0.09. What is the ratio of the Stocks(% of exports of goods, services and primary income) in Guyana in 1997 to that in 1999?
Make the answer very short. 1.01. What is the ratio of the Stocks(% of exports of goods, services and primary income) in Bulgaria in 1997 to that in 2000?
Provide a short and direct response. 1.04. What is the ratio of the Stocks(% of exports of goods, services and primary income) of Eritrea in 1997 to that in 2000?
Offer a terse response. 0.11. What is the ratio of the Stocks(% of exports of goods, services and primary income) of Guyana in 1997 to that in 2000?
Offer a terse response. 1.05. What is the ratio of the Stocks(% of exports of goods, services and primary income) of Bulgaria in 1998 to that in 1999?
Ensure brevity in your answer.  0.93. What is the ratio of the Stocks(% of exports of goods, services and primary income) of Eritrea in 1998 to that in 1999?
Your answer should be compact. 0.34. What is the ratio of the Stocks(% of exports of goods, services and primary income) in Guyana in 1998 to that in 1999?
Provide a short and direct response. 1.01. What is the ratio of the Stocks(% of exports of goods, services and primary income) in Bulgaria in 1998 to that in 2000?
Make the answer very short. 1.1. What is the ratio of the Stocks(% of exports of goods, services and primary income) in Eritrea in 1998 to that in 2000?
Your answer should be very brief. 0.39. What is the ratio of the Stocks(% of exports of goods, services and primary income) in Guyana in 1998 to that in 2000?
Keep it short and to the point. 1.05. What is the ratio of the Stocks(% of exports of goods, services and primary income) in Bulgaria in 1999 to that in 2000?
Offer a terse response. 1.19. What is the ratio of the Stocks(% of exports of goods, services and primary income) of Eritrea in 1999 to that in 2000?
Your response must be concise. 1.16. What is the ratio of the Stocks(% of exports of goods, services and primary income) of Guyana in 1999 to that in 2000?
Make the answer very short. 1.04. What is the difference between the highest and the second highest Stocks(% of exports of goods, services and primary income) of Bulgaria?
Your response must be concise. 9.2. What is the difference between the highest and the second highest Stocks(% of exports of goods, services and primary income) of Eritrea?
Make the answer very short. 47.86. What is the difference between the highest and the second highest Stocks(% of exports of goods, services and primary income) in Guyana?
Make the answer very short. 15.79. What is the difference between the highest and the lowest Stocks(% of exports of goods, services and primary income) of Bulgaria?
Your answer should be very brief. 45.61. What is the difference between the highest and the lowest Stocks(% of exports of goods, services and primary income) of Eritrea?
Offer a terse response. 339.45. What is the difference between the highest and the lowest Stocks(% of exports of goods, services and primary income) of Guyana?
Your answer should be very brief. 143.7. 